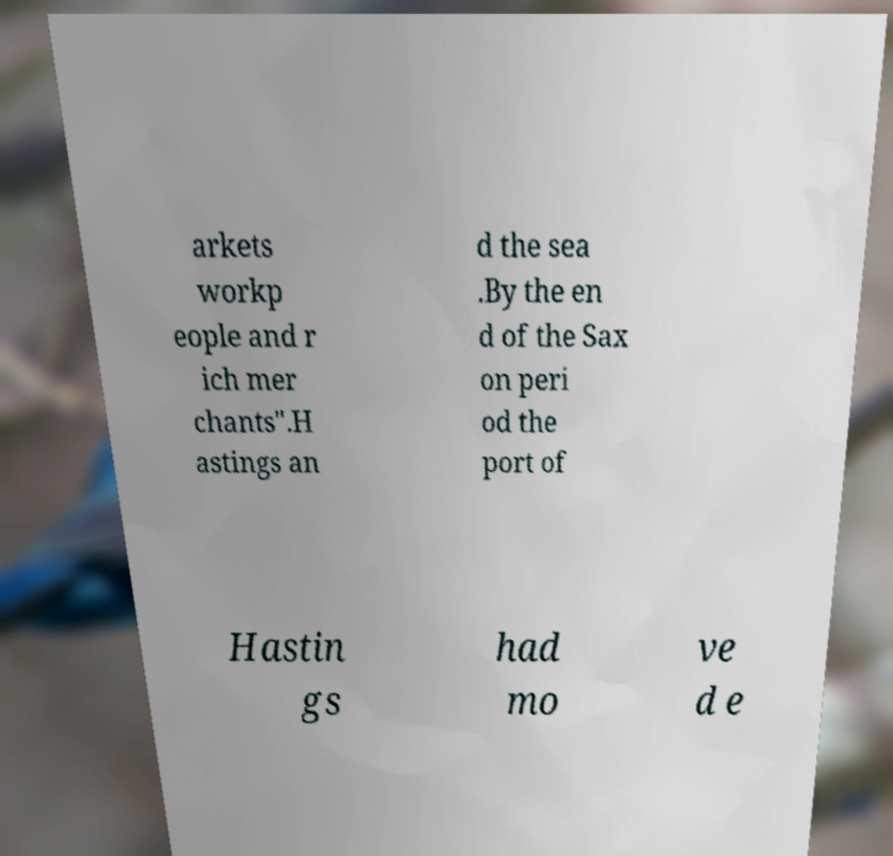For documentation purposes, I need the text within this image transcribed. Could you provide that? arkets workp eople and r ich mer chants".H astings an d the sea .By the en d of the Sax on peri od the port of Hastin gs had mo ve d e 